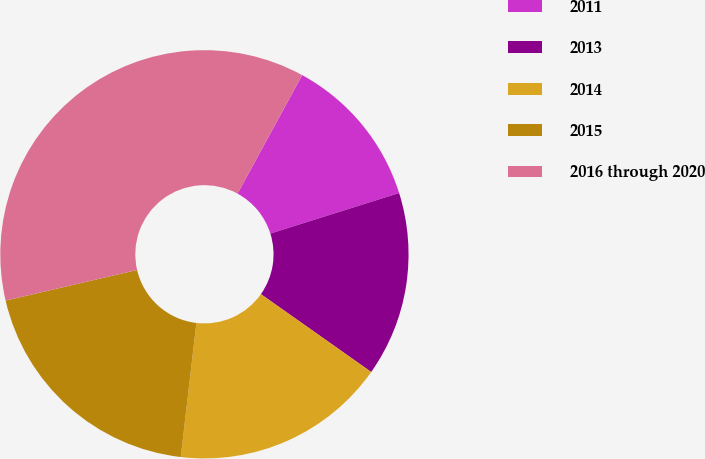<chart> <loc_0><loc_0><loc_500><loc_500><pie_chart><fcel>2011<fcel>2013<fcel>2014<fcel>2015<fcel>2016 through 2020<nl><fcel>12.2%<fcel>14.63%<fcel>17.07%<fcel>19.51%<fcel>36.59%<nl></chart> 